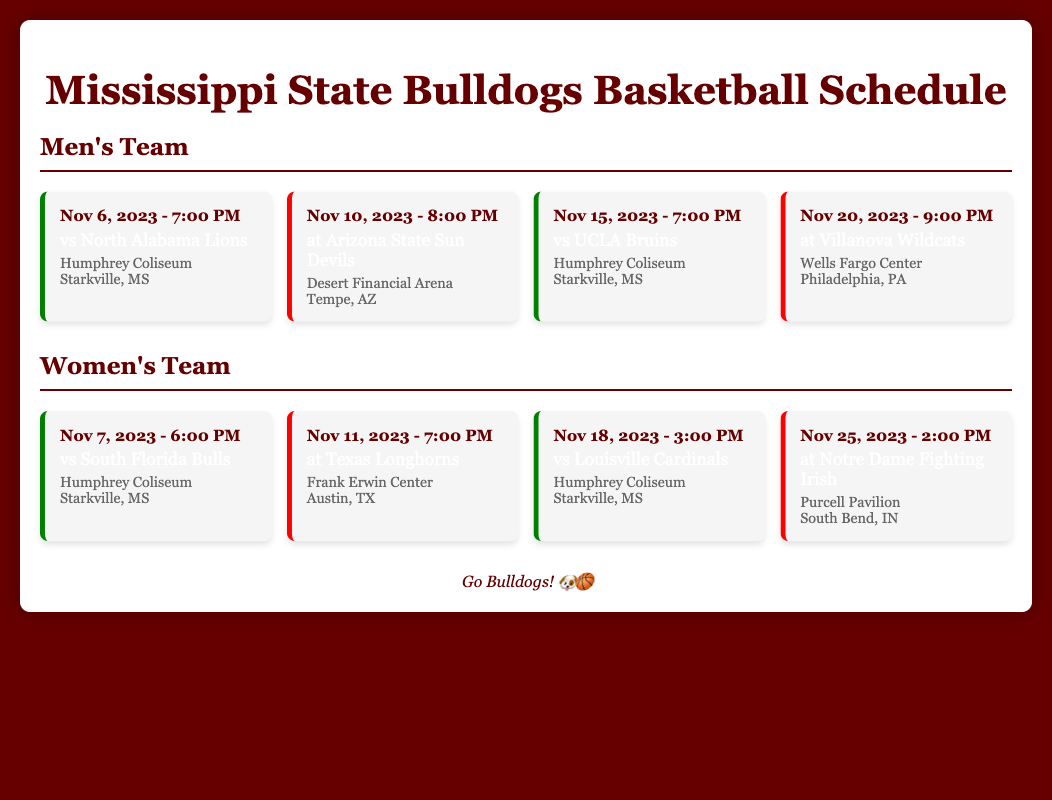What date is the men's game against North Alabama? The date for the game against North Alabama is listed in the schedule under the men's section.
Answer: Nov 6, 2023 What is the venue for the women's game against South Florida? The venue for the game against South Florida is included in the women's team's schedule.
Answer: Humphrey Coliseum Which team plays against the men's team on November 15? The opponent for the men's team on November 15 can be found in the respective entry of the schedule.
Answer: UCLA Bruins How many away games does the women's team have in November? The document includes entries for each game, allowing for a count of away games in November.
Answer: 2 What time is the women's game against Louisville? The time is specified in the schedule for the women's game against Louisville.
Answer: 3:00 PM Which team is the opponent for the men's team on November 20? The opponent is clearly stated in the schedule for the specified date in the men's section.
Answer: Villanova Wildcats What color represents home games in the document? The document describes a color coding system for home games in the styling of the schedule.
Answer: Green What city hosts the men's game against Arizona State? The location for the away game against Arizona State is provided in the men's schedule.
Answer: Tempe, AZ 